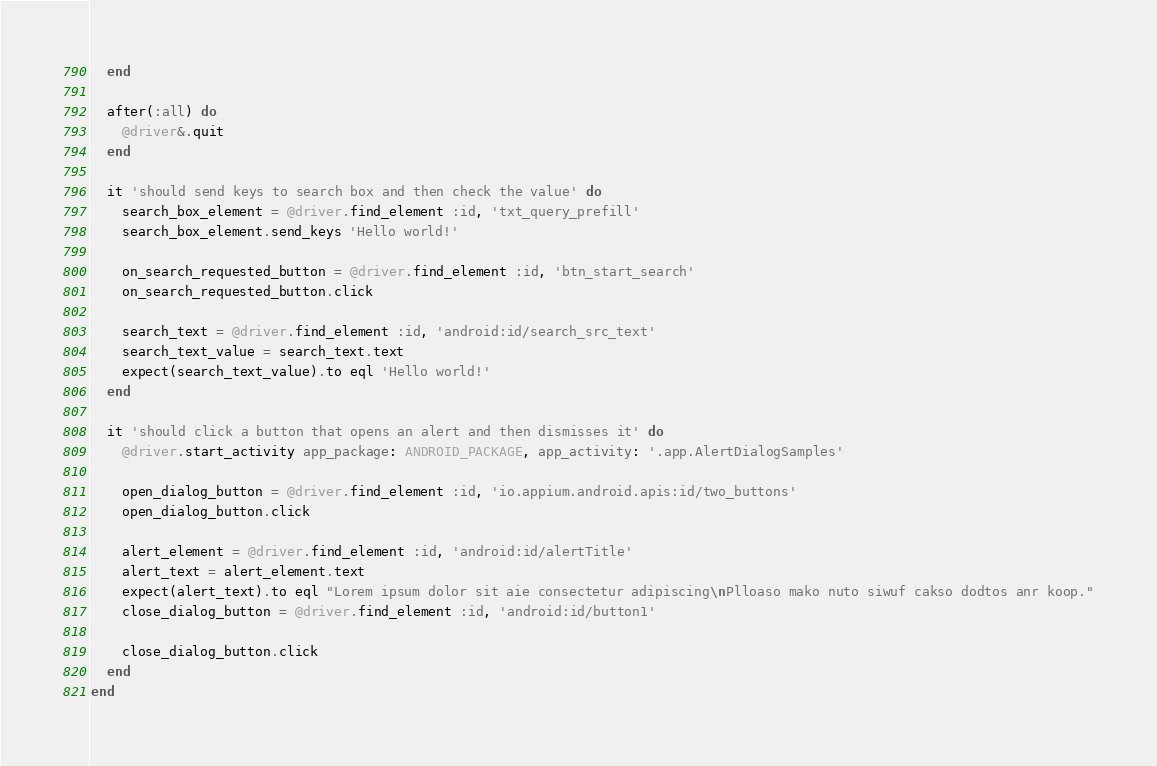Convert code to text. <code><loc_0><loc_0><loc_500><loc_500><_Ruby_>  end

  after(:all) do
    @driver&.quit
  end

  it 'should send keys to search box and then check the value' do
    search_box_element = @driver.find_element :id, 'txt_query_prefill'
    search_box_element.send_keys 'Hello world!'

    on_search_requested_button = @driver.find_element :id, 'btn_start_search'
    on_search_requested_button.click

    search_text = @driver.find_element :id, 'android:id/search_src_text'
    search_text_value = search_text.text
    expect(search_text_value).to eql 'Hello world!'
  end

  it 'should click a button that opens an alert and then dismisses it' do
    @driver.start_activity app_package: ANDROID_PACKAGE, app_activity: '.app.AlertDialogSamples'

    open_dialog_button = @driver.find_element :id, 'io.appium.android.apis:id/two_buttons'
    open_dialog_button.click

    alert_element = @driver.find_element :id, 'android:id/alertTitle'
    alert_text = alert_element.text
    expect(alert_text).to eql "Lorem ipsum dolor sit aie consectetur adipiscing\nPlloaso mako nuto siwuf cakso dodtos anr koop."
    close_dialog_button = @driver.find_element :id, 'android:id/button1'

    close_dialog_button.click
  end
end
</code> 